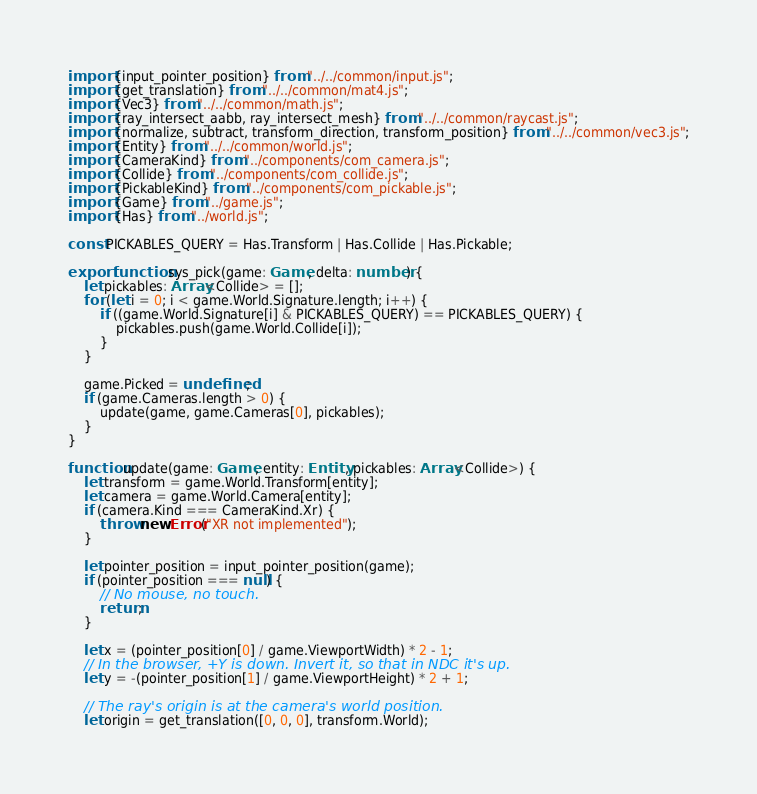<code> <loc_0><loc_0><loc_500><loc_500><_TypeScript_>import {input_pointer_position} from "../../common/input.js";
import {get_translation} from "../../common/mat4.js";
import {Vec3} from "../../common/math.js";
import {ray_intersect_aabb, ray_intersect_mesh} from "../../common/raycast.js";
import {normalize, subtract, transform_direction, transform_position} from "../../common/vec3.js";
import {Entity} from "../../common/world.js";
import {CameraKind} from "../components/com_camera.js";
import {Collide} from "../components/com_collide.js";
import {PickableKind} from "../components/com_pickable.js";
import {Game} from "../game.js";
import {Has} from "../world.js";

const PICKABLES_QUERY = Has.Transform | Has.Collide | Has.Pickable;

export function sys_pick(game: Game, delta: number) {
    let pickables: Array<Collide> = [];
    for (let i = 0; i < game.World.Signature.length; i++) {
        if ((game.World.Signature[i] & PICKABLES_QUERY) == PICKABLES_QUERY) {
            pickables.push(game.World.Collide[i]);
        }
    }

    game.Picked = undefined;
    if (game.Cameras.length > 0) {
        update(game, game.Cameras[0], pickables);
    }
}

function update(game: Game, entity: Entity, pickables: Array<Collide>) {
    let transform = game.World.Transform[entity];
    let camera = game.World.Camera[entity];
    if (camera.Kind === CameraKind.Xr) {
        throw new Error("XR not implemented");
    }

    let pointer_position = input_pointer_position(game);
    if (pointer_position === null) {
        // No mouse, no touch.
        return;
    }

    let x = (pointer_position[0] / game.ViewportWidth) * 2 - 1;
    // In the browser, +Y is down. Invert it, so that in NDC it's up.
    let y = -(pointer_position[1] / game.ViewportHeight) * 2 + 1;

    // The ray's origin is at the camera's world position.
    let origin = get_translation([0, 0, 0], transform.World);
</code> 